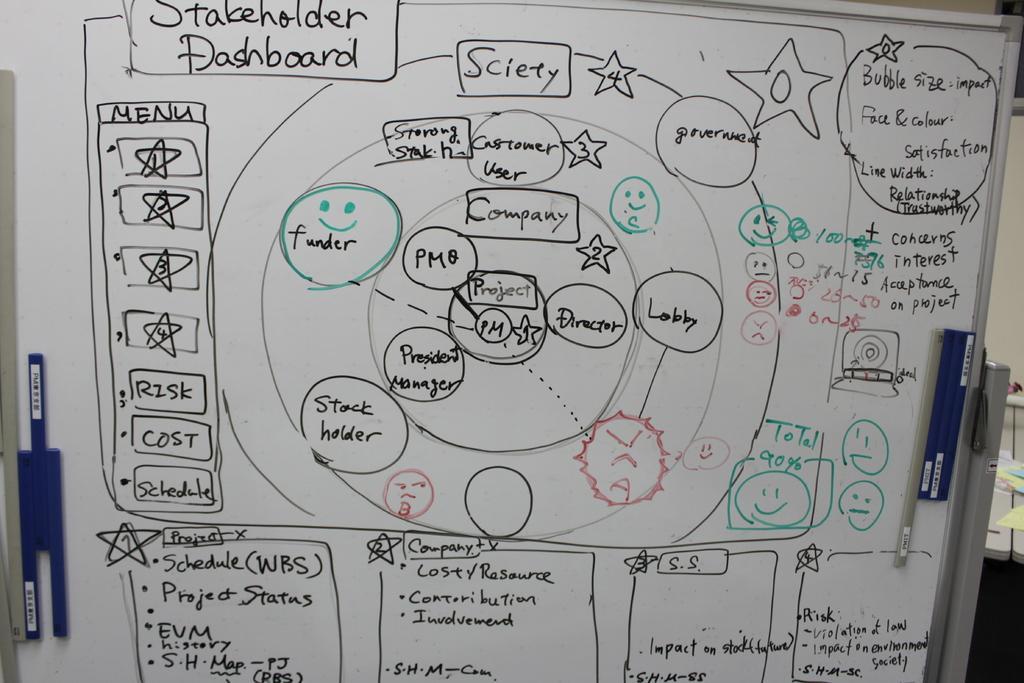Could you give a brief overview of what you see in this image? In this picture we can see a white board in the front, we can see handwritten text on this board. 